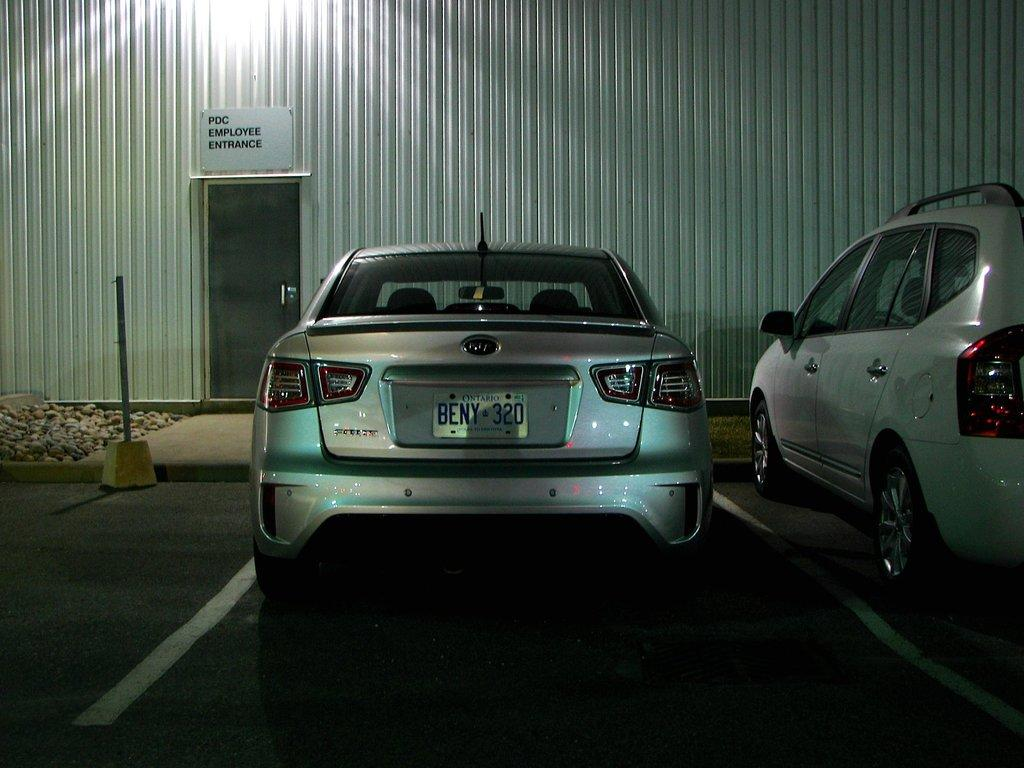What can be seen on the road in the image? There are vehicles on the road in the image. What type of objects are visible on the ground in the image? There are stones visible in the image. What structure can be seen in the image? There is a pole in the image. What architectural feature is present in the image? There is a door in the image. What type of surface is present in the image? There is a wall in the image. What is written on the wall in the image? There is a poster with text on the wall in the image. How many apples are hanging from the pole in the image? There are no apples present in the image; only stones, vehicles, a pole, a door, a wall, and a poster with text are visible. Can you tell me what the poster is talking about in the image? The poster does not talk; it has text on it, but there is no indication of what it is discussing. 